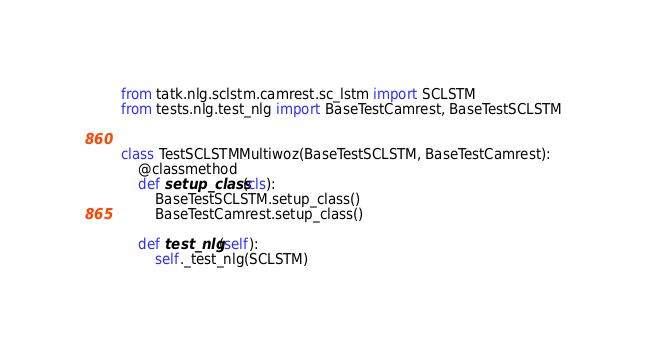<code> <loc_0><loc_0><loc_500><loc_500><_Python_>from tatk.nlg.sclstm.camrest.sc_lstm import SCLSTM
from tests.nlg.test_nlg import BaseTestCamrest, BaseTestSCLSTM


class TestSCLSTMMultiwoz(BaseTestSCLSTM, BaseTestCamrest):
    @classmethod
    def setup_class(cls):
        BaseTestSCLSTM.setup_class()
        BaseTestCamrest.setup_class()

    def test_nlg(self):
        self._test_nlg(SCLSTM)
</code> 